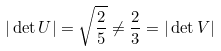<formula> <loc_0><loc_0><loc_500><loc_500>| \det U | = \sqrt { \frac { 2 } { 5 } } \neq \frac { 2 } { 3 } = | \det V |</formula> 